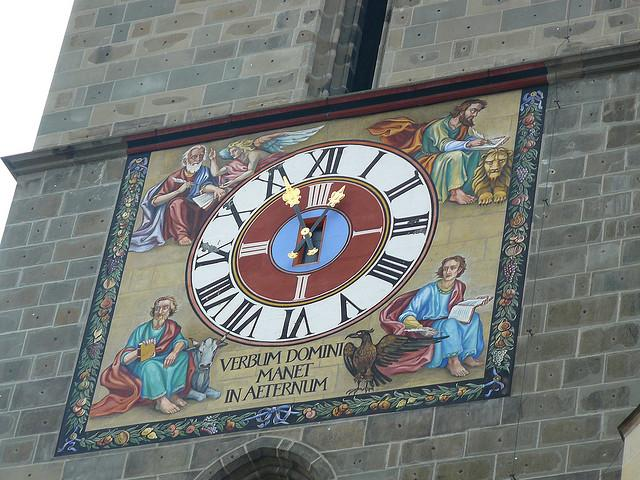What language are the words on the clock written in? latin 